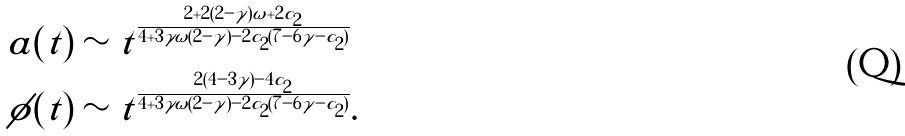<formula> <loc_0><loc_0><loc_500><loc_500>a ( t ) & \sim t ^ { \frac { 2 + 2 ( 2 - \gamma ) \omega + 2 c _ { 2 } } { 4 + 3 \gamma \omega ( 2 - \gamma ) - 2 c _ { 2 } ( 7 - 6 \gamma - c _ { 2 } ) } } \\ \phi ( t ) & \sim t ^ { \frac { 2 ( 4 - 3 \gamma ) - 4 c _ { 2 } } { 4 + 3 \gamma \omega ( 2 - \gamma ) - 2 c _ { 2 } ( 7 - 6 \gamma - c _ { 2 } ) } } .</formula> 